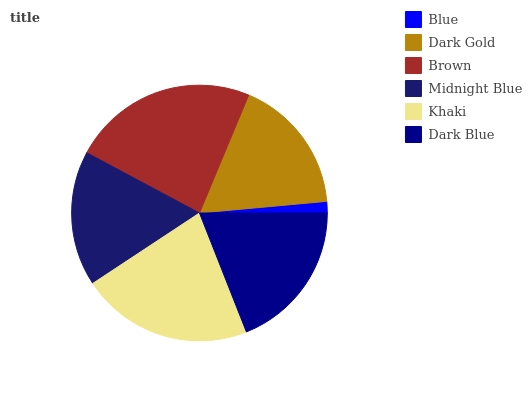Is Blue the minimum?
Answer yes or no. Yes. Is Brown the maximum?
Answer yes or no. Yes. Is Dark Gold the minimum?
Answer yes or no. No. Is Dark Gold the maximum?
Answer yes or no. No. Is Dark Gold greater than Blue?
Answer yes or no. Yes. Is Blue less than Dark Gold?
Answer yes or no. Yes. Is Blue greater than Dark Gold?
Answer yes or no. No. Is Dark Gold less than Blue?
Answer yes or no. No. Is Dark Blue the high median?
Answer yes or no. Yes. Is Dark Gold the low median?
Answer yes or no. Yes. Is Brown the high median?
Answer yes or no. No. Is Brown the low median?
Answer yes or no. No. 